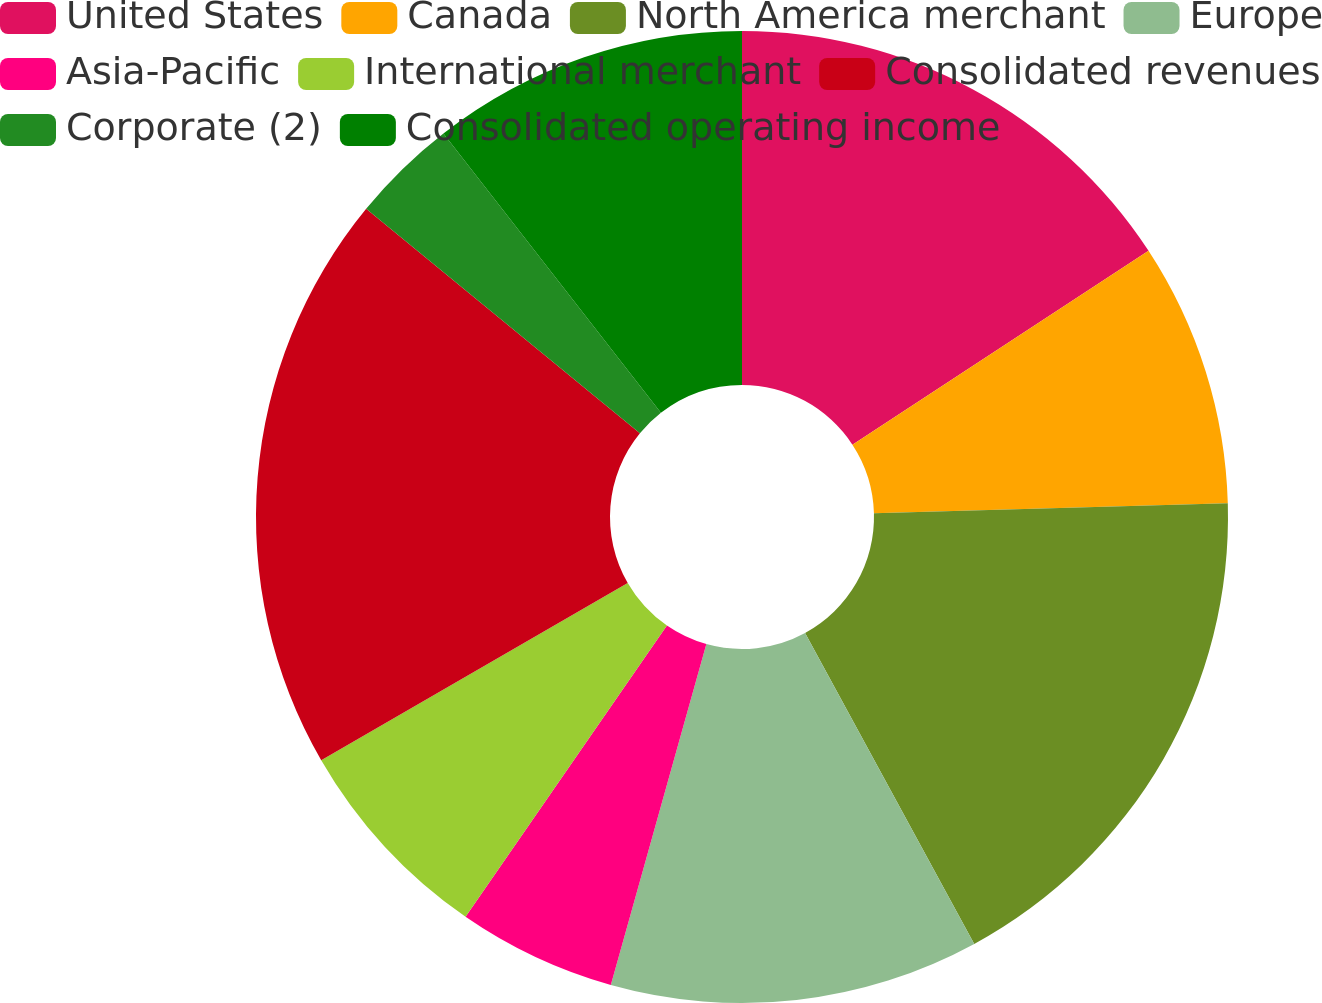Convert chart to OTSL. <chart><loc_0><loc_0><loc_500><loc_500><pie_chart><fcel>United States<fcel>Canada<fcel>North America merchant<fcel>Europe<fcel>Asia-Pacific<fcel>International merchant<fcel>Consolidated revenues<fcel>Corporate (2)<fcel>Consolidated operating income<nl><fcel>15.77%<fcel>8.78%<fcel>17.52%<fcel>12.28%<fcel>5.28%<fcel>7.03%<fcel>19.27%<fcel>3.54%<fcel>10.53%<nl></chart> 